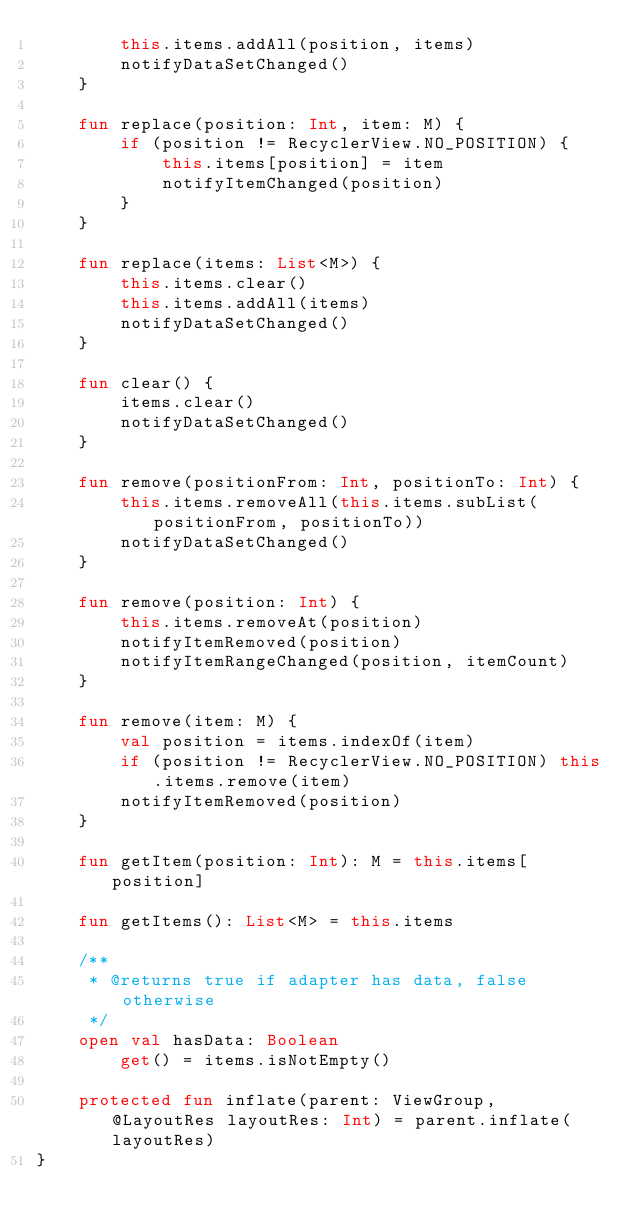<code> <loc_0><loc_0><loc_500><loc_500><_Kotlin_>        this.items.addAll(position, items)
        notifyDataSetChanged()
    }

    fun replace(position: Int, item: M) {
        if (position != RecyclerView.NO_POSITION) {
            this.items[position] = item
            notifyItemChanged(position)
        }
    }

    fun replace(items: List<M>) {
        this.items.clear()
        this.items.addAll(items)
        notifyDataSetChanged()
    }

    fun clear() {
        items.clear()
        notifyDataSetChanged()
    }

    fun remove(positionFrom: Int, positionTo: Int) {
        this.items.removeAll(this.items.subList(positionFrom, positionTo))
        notifyDataSetChanged()
    }

    fun remove(position: Int) {
        this.items.removeAt(position)
        notifyItemRemoved(position)
        notifyItemRangeChanged(position, itemCount)
    }

    fun remove(item: M) {
        val position = items.indexOf(item)
        if (position != RecyclerView.NO_POSITION) this.items.remove(item)
        notifyItemRemoved(position)
    }

    fun getItem(position: Int): M = this.items[position]

    fun getItems(): List<M> = this.items

    /**
     * @returns true if adapter has data, false otherwise
     */
    open val hasData: Boolean
        get() = items.isNotEmpty()

    protected fun inflate(parent: ViewGroup, @LayoutRes layoutRes: Int) = parent.inflate(layoutRes)
}</code> 